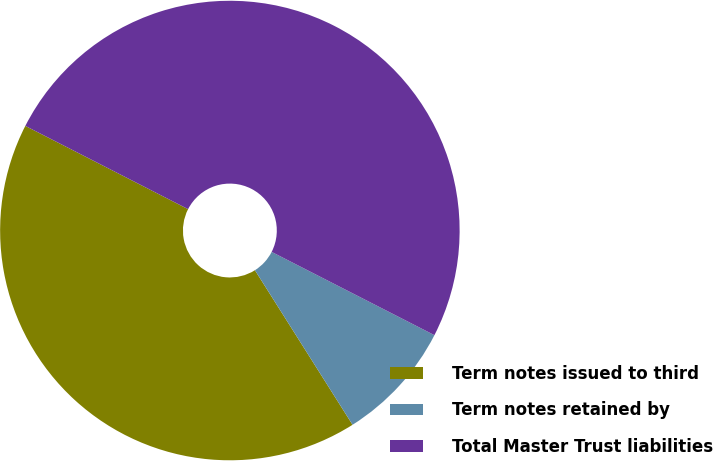Convert chart to OTSL. <chart><loc_0><loc_0><loc_500><loc_500><pie_chart><fcel>Term notes issued to third<fcel>Term notes retained by<fcel>Total Master Trust liabilities<nl><fcel>41.49%<fcel>8.51%<fcel>50.0%<nl></chart> 